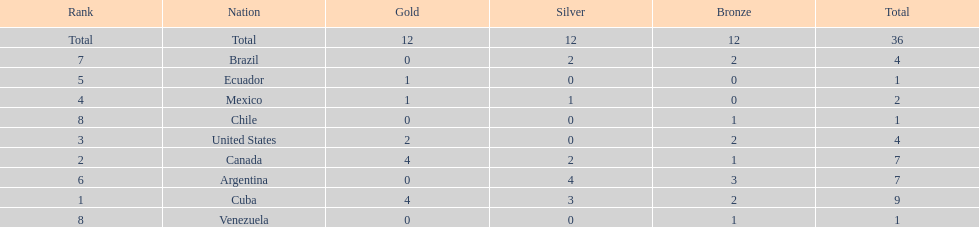In which position does mexico rank? 4. 